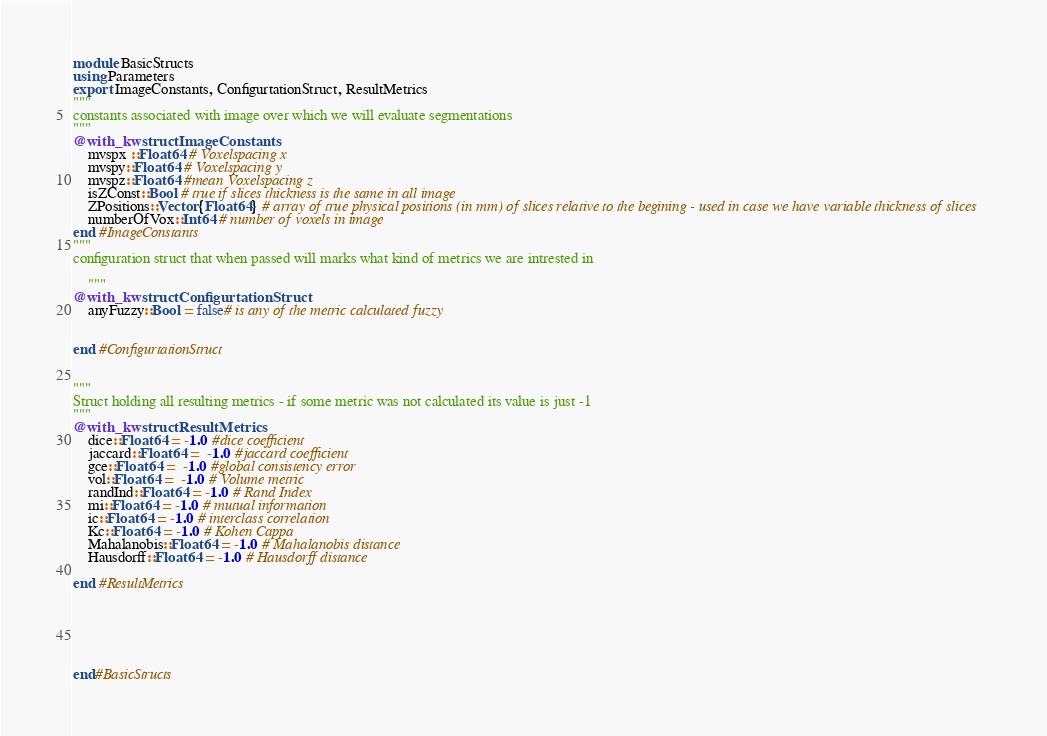Convert code to text. <code><loc_0><loc_0><loc_500><loc_500><_Julia_>
module BasicStructs
using Parameters
export ImageConstants, ConfigurtationStruct, ResultMetrics
"""
constants associated with image over which we will evaluate segmentations
"""
@with_kw struct ImageConstants
    mvspx ::Float64 # Voxelspacing x 
    mvspy::Float64 # Voxelspacing y
    mvspz::Float64 #mean Voxelspacing z
    isZConst::Bool # true if slices thickness is the same in all image
    ZPositions::Vector{Float64} # array of true physical positions (in mm) of slices relative to the begining - used in case we have variable thickness of slices
    numberOfVox::Int64 # number of voxels in image
end #ImageConstants
"""
configuration struct that when passed will marks what kind of metrics we are intrested in 
    
    """
@with_kw struct ConfigurtationStruct
    anyFuzzy::Bool = false# is any of the metric calculated fuzzy
    

end #ConfigurtationStruct


"""
Struct holding all resulting metrics - if some metric was not calculated its value is just -1  
"""
@with_kw struct ResultMetrics
    dice::Float64 = -1.0 #dice coefficient
    jaccard::Float64 =  -1.0 #jaccard coefficient
    gce::Float64 =  -1.0 #global consistency error
    vol::Float64 =  -1.0 # Volume metric
    randInd::Float64 = -1.0 # Rand Index 
    mi::Float64 = -1.0 # mutual information
    ic::Float64 = -1.0 # interclass correlation
    Kc::Float64 = -1.0 # Kohen Cappa
    Mahalanobis::Float64 = -1.0 # Mahalanobis distance
    Hausdorff::Float64 = -1.0 # Hausdorff distance

end #ResultMetrics






end#BasicStructs
</code> 